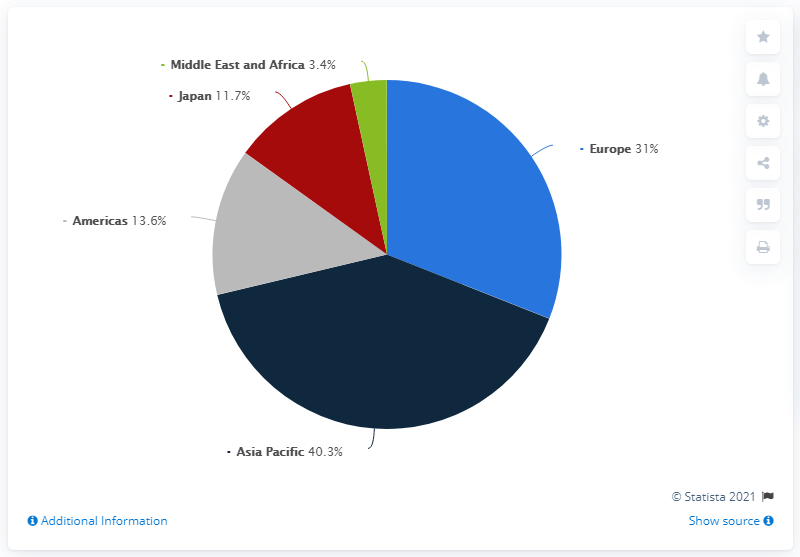Highlight a few significant elements in this photo. The sum value of Japan and Europe is greater than that of the Asia Pacific region. The red color in the pie segment indicates the presence of Japan. 